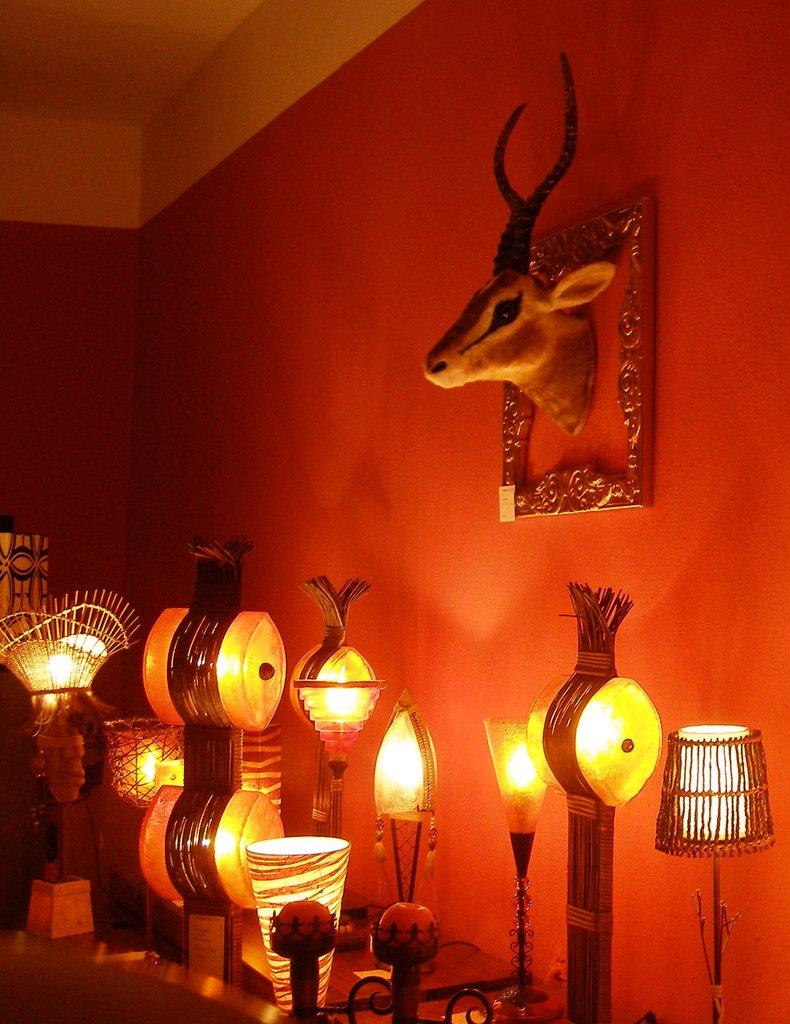What objects are located at the bottom of the image? There are table lamps at the bottom of the image. What can be seen in the background of the image? There is a wall in the background of the image. What type of showpiece is present in the image? There is an animal-shaped showpiece in the image. What is the purpose of the frame in the image? The frame is likely used to hold a picture or artwork. What is visible at the top of the image? The ceiling is visible at the top of the image. What type of soup is being served in the mine in the image? There is no mine or soup present in the image. How many chairs are visible in the image? There is no mention of chairs in the provided facts, so we cannot determine the number of chairs in the image. 